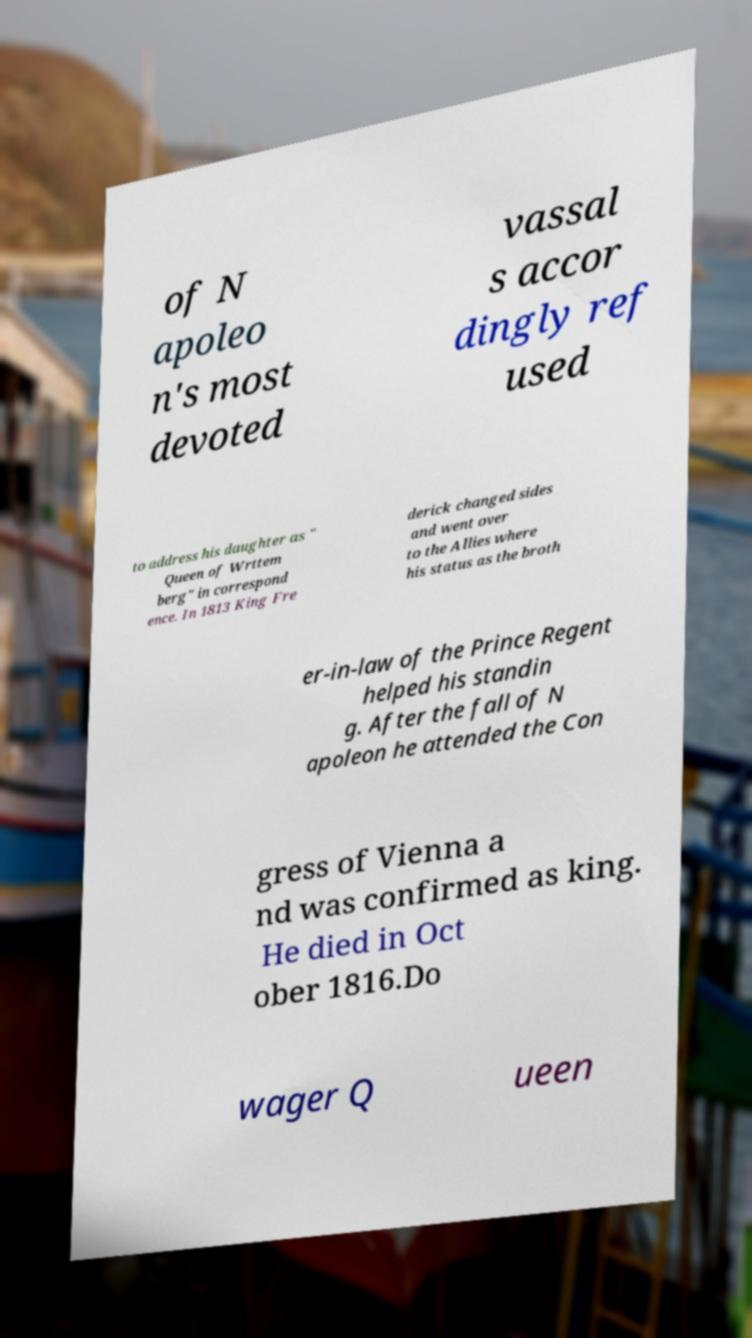For documentation purposes, I need the text within this image transcribed. Could you provide that? of N apoleo n's most devoted vassal s accor dingly ref used to address his daughter as " Queen of Wrttem berg" in correspond ence. In 1813 King Fre derick changed sides and went over to the Allies where his status as the broth er-in-law of the Prince Regent helped his standin g. After the fall of N apoleon he attended the Con gress of Vienna a nd was confirmed as king. He died in Oct ober 1816.Do wager Q ueen 